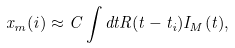Convert formula to latex. <formula><loc_0><loc_0><loc_500><loc_500>x _ { m } ( i ) \approx C \int d t R ( t - t _ { i } ) I _ { M } ( t ) ,</formula> 